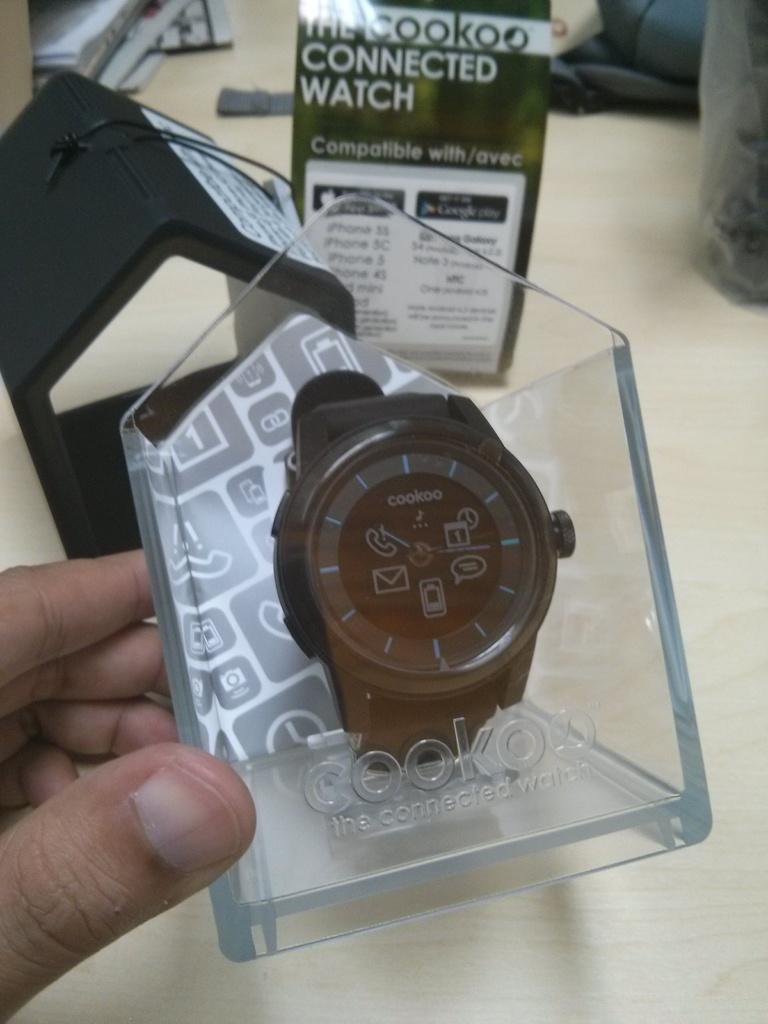What is the brand of the watch?
Your response must be concise. Cookoo. What is this brand of watch called?
Your response must be concise. Cookoo. 